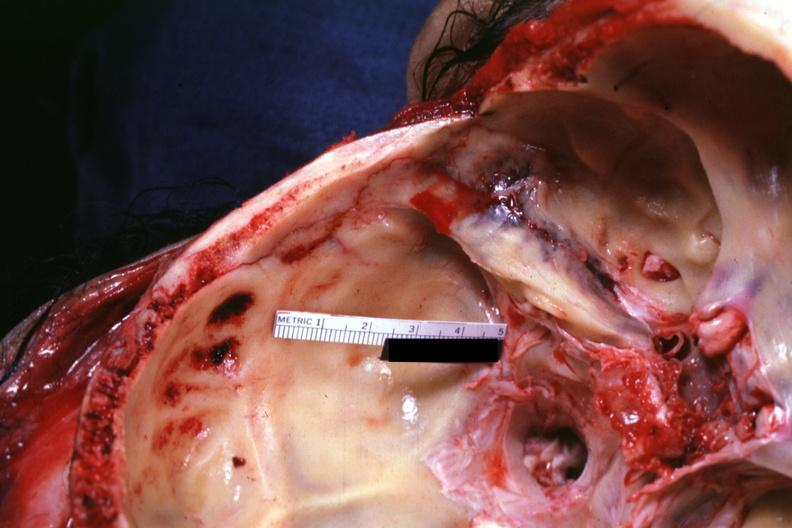s basilar skull fracture present?
Answer the question using a single word or phrase. Yes 